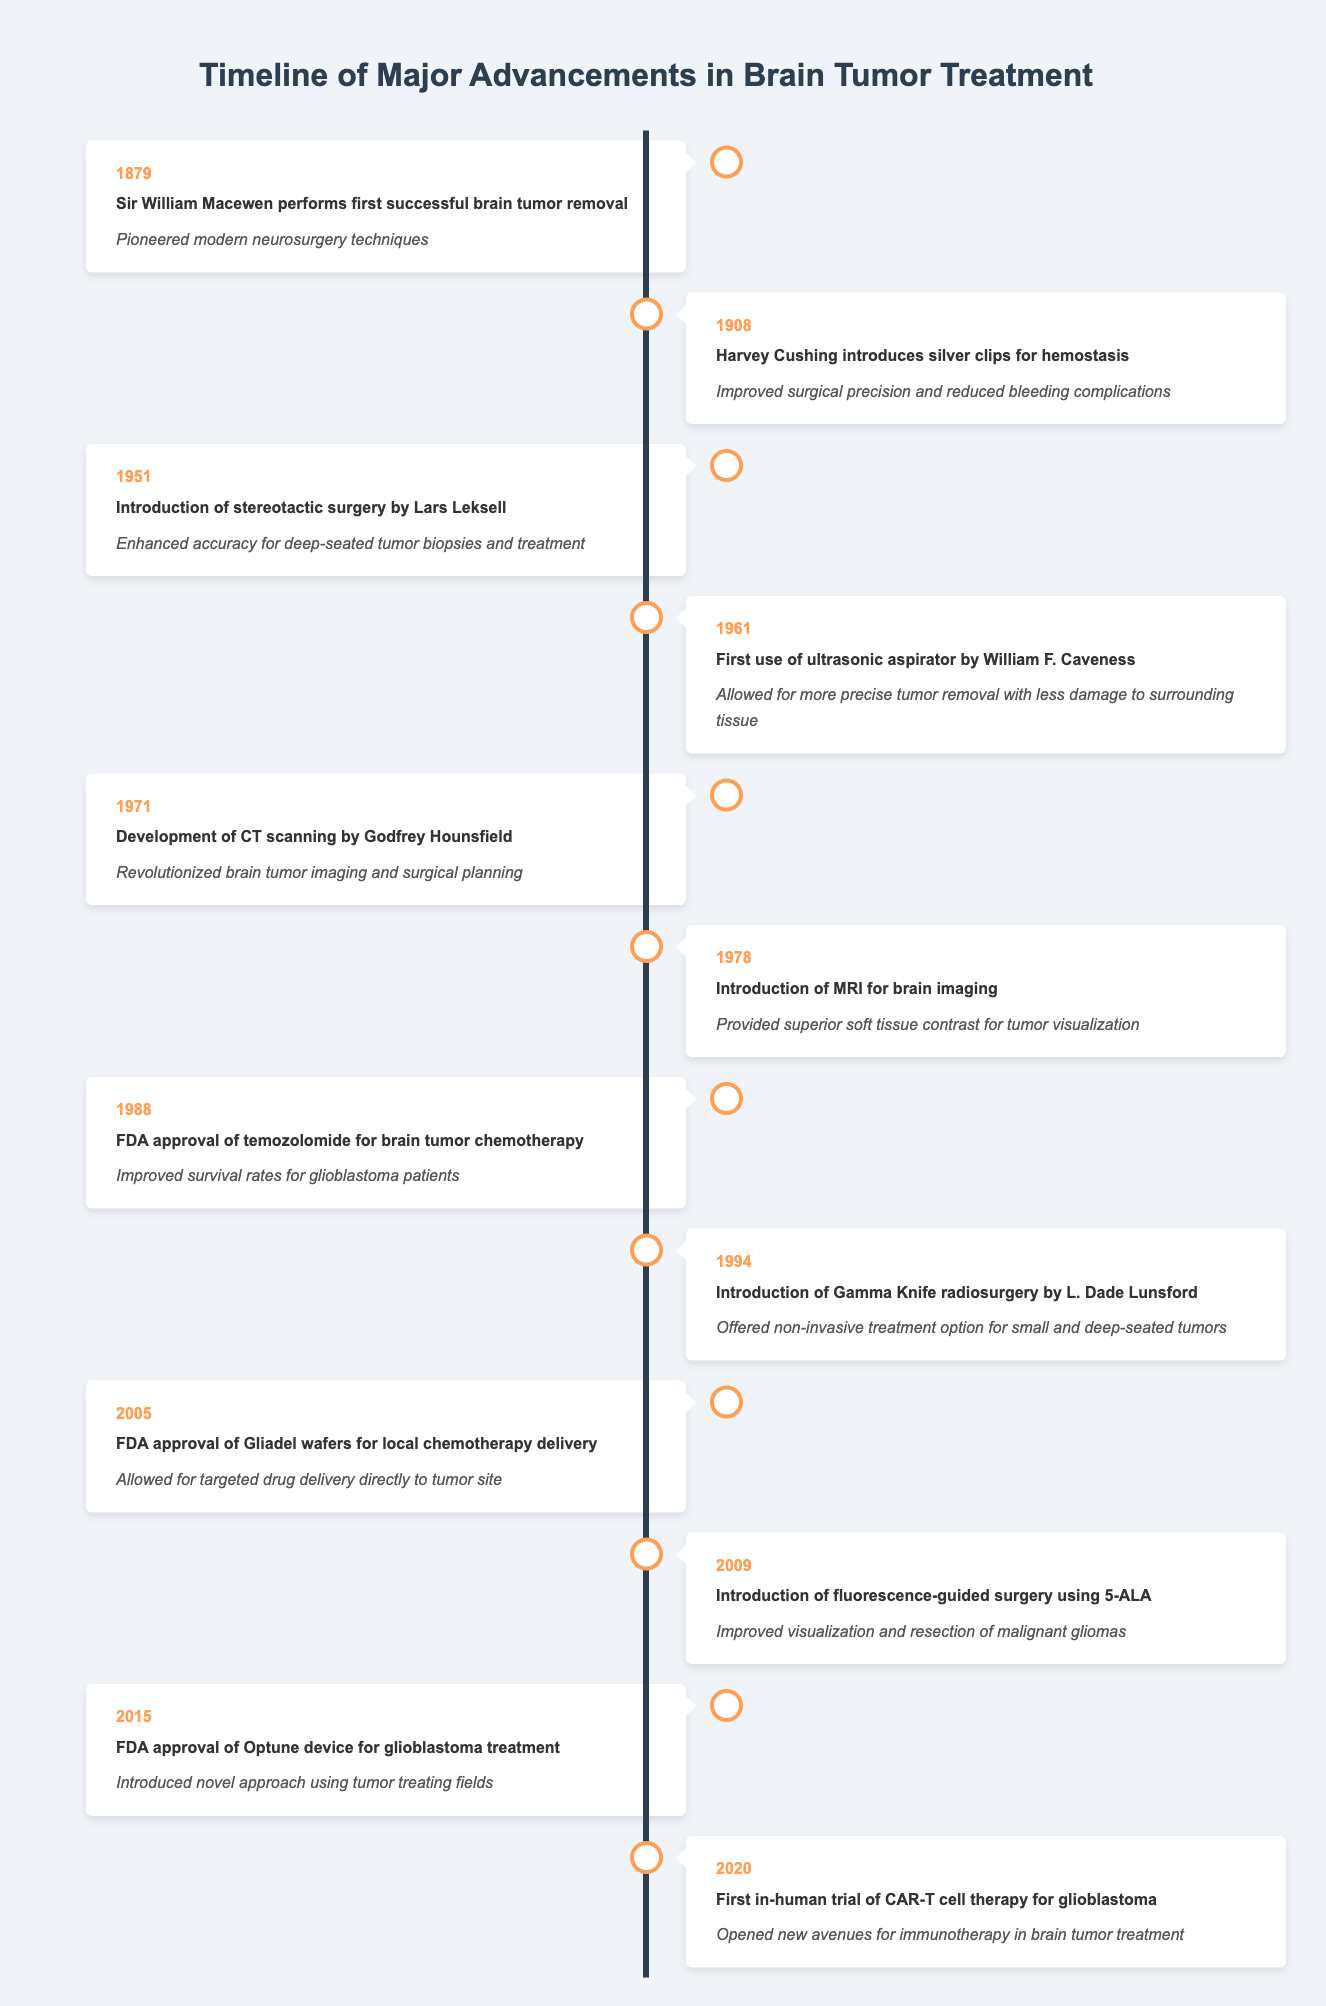What year did Sir William Macewen perform the first successful brain tumor removal? The event "Sir William Macewen performs first successful brain tumor removal" is listed under the year 1879. Thus, the answer is directly found in that row.
Answer: 1879 What was introduced in 1988 that improved survival rates for glioblastoma patients? The event for 1988 states "FDA approval of temozolomide for brain tumor chemotherapy," indicating that this drug was introduced to improve survival rates for glioblastoma patients.
Answer: Temozolomide How many years apart were the introductions of MRI for brain imaging and CT scanning? MRI was introduced in 1978 and CT scanning in 1971. Calculating the difference gives us 1978 - 1971 = 7 years apart.
Answer: 7 years Was the first in-human trial of CAR-T cell therapy for glioblastoma conducted before 2015? The event for the first in-human trial of CAR-T cell therapy occurred in 2020. Since 2020 is after 2015, the answer is no.
Answer: No Which advancement occurred first, the introduction of fluorescence-guided surgery or the FDA approval of Gliadel wafers? Fluorescence-guided surgery was introduced in 2009, while Gliadel wafers received FDA approval in 2005. Thus, the Gliadel wafers were introduced first.
Answer: FDA approval of Gliadel wafers What are the two significant technological advancements introduced in the 1970s? From the table, CT scanning was developed in 1971 and MRI was introduced in 1978. Both are significant technological advancements in brain tumor treatment from that decade.
Answer: CT scanning and MRI Which event improved surgical precision and reduced bleeding complications? The event "Harvey Cushing introduces silver clips for hemostasis" in 1908 directly states that this improvement was made for surgical precision and bleeding complications.
Answer: Introducing silver clips for hemostasis List the key significance of the introduction of Gamma Knife radiosurgery in 1994. The event states "Offered non-invasive treatment option for small and deep-seated tumors," highlighting its primary significance in brain tumor treatment.
Answer: Non-invasive treatment option for small and deep-seated tumors What has been the trend regarding new treatments for brain tumors from 2005 to 2020? Analyzing the timeline from 2005 (FDA approval of Gliadel wafers) to 2020 (first in-human trial of CAR-T cell therapy), there has been a steady progression towards more innovative treatments, including immunotherapy and local drug delivery systems.
Answer: Progressive trend towards innovative treatments 